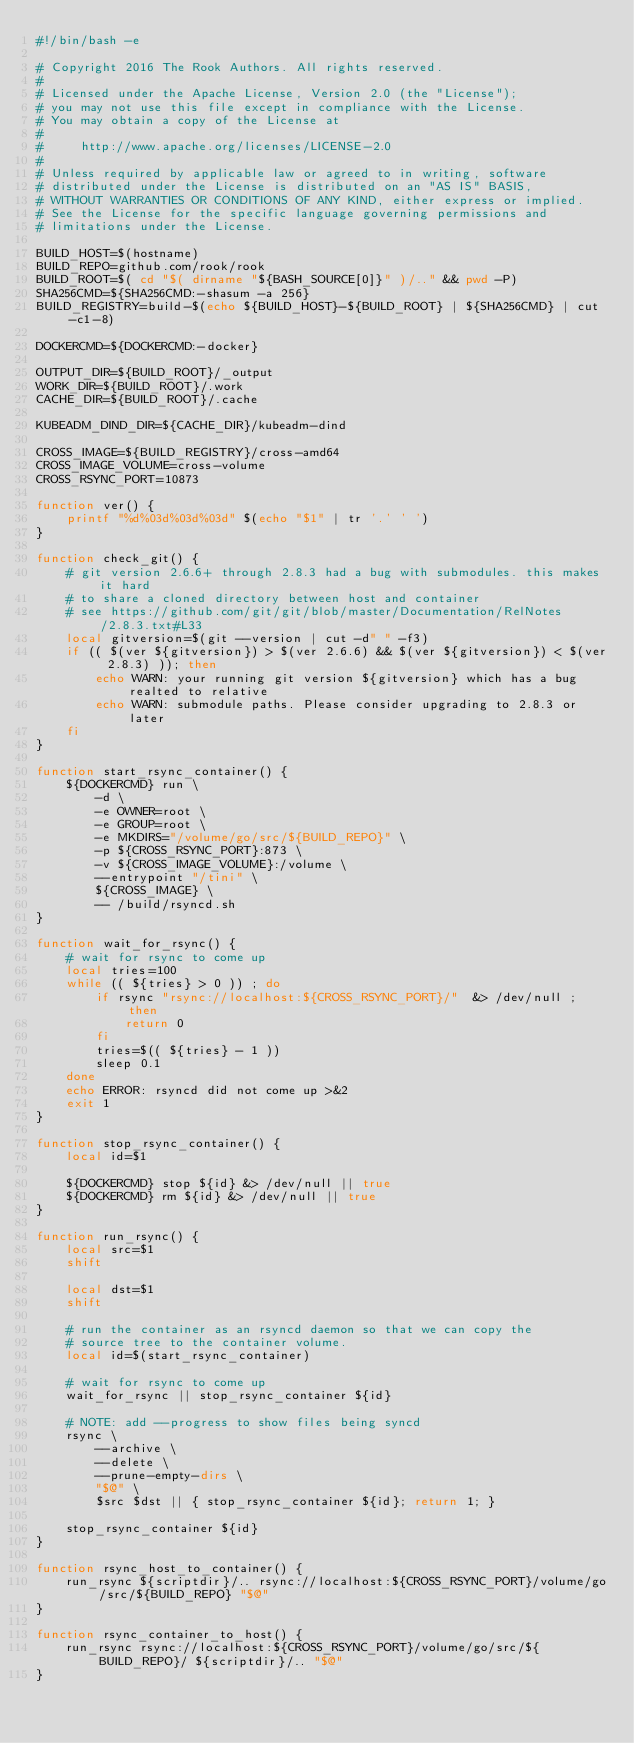<code> <loc_0><loc_0><loc_500><loc_500><_Bash_>#!/bin/bash -e

# Copyright 2016 The Rook Authors. All rights reserved.
#
# Licensed under the Apache License, Version 2.0 (the "License");
# you may not use this file except in compliance with the License.
# You may obtain a copy of the License at
#
#     http://www.apache.org/licenses/LICENSE-2.0
#
# Unless required by applicable law or agreed to in writing, software
# distributed under the License is distributed on an "AS IS" BASIS,
# WITHOUT WARRANTIES OR CONDITIONS OF ANY KIND, either express or implied.
# See the License for the specific language governing permissions and
# limitations under the License.

BUILD_HOST=$(hostname)
BUILD_REPO=github.com/rook/rook
BUILD_ROOT=$( cd "$( dirname "${BASH_SOURCE[0]}" )/.." && pwd -P)
SHA256CMD=${SHA256CMD:-shasum -a 256}
BUILD_REGISTRY=build-$(echo ${BUILD_HOST}-${BUILD_ROOT} | ${SHA256CMD} | cut -c1-8)

DOCKERCMD=${DOCKERCMD:-docker}

OUTPUT_DIR=${BUILD_ROOT}/_output
WORK_DIR=${BUILD_ROOT}/.work
CACHE_DIR=${BUILD_ROOT}/.cache

KUBEADM_DIND_DIR=${CACHE_DIR}/kubeadm-dind

CROSS_IMAGE=${BUILD_REGISTRY}/cross-amd64
CROSS_IMAGE_VOLUME=cross-volume
CROSS_RSYNC_PORT=10873

function ver() {
    printf "%d%03d%03d%03d" $(echo "$1" | tr '.' ' ')
}

function check_git() {
    # git version 2.6.6+ through 2.8.3 had a bug with submodules. this makes it hard
    # to share a cloned directory between host and container
    # see https://github.com/git/git/blob/master/Documentation/RelNotes/2.8.3.txt#L33
    local gitversion=$(git --version | cut -d" " -f3)
    if (( $(ver ${gitversion}) > $(ver 2.6.6) && $(ver ${gitversion}) < $(ver 2.8.3) )); then
        echo WARN: your running git version ${gitversion} which has a bug realted to relative
        echo WARN: submodule paths. Please consider upgrading to 2.8.3 or later
    fi
}

function start_rsync_container() {
    ${DOCKERCMD} run \
        -d \
        -e OWNER=root \
        -e GROUP=root \
        -e MKDIRS="/volume/go/src/${BUILD_REPO}" \
        -p ${CROSS_RSYNC_PORT}:873 \
        -v ${CROSS_IMAGE_VOLUME}:/volume \
        --entrypoint "/tini" \
        ${CROSS_IMAGE} \
        -- /build/rsyncd.sh
}

function wait_for_rsync() {
    # wait for rsync to come up
    local tries=100
    while (( ${tries} > 0 )) ; do
        if rsync "rsync://localhost:${CROSS_RSYNC_PORT}/"  &> /dev/null ; then
            return 0
        fi
        tries=$(( ${tries} - 1 ))
        sleep 0.1
    done
    echo ERROR: rsyncd did not come up >&2
    exit 1
}

function stop_rsync_container() {
    local id=$1

    ${DOCKERCMD} stop ${id} &> /dev/null || true
    ${DOCKERCMD} rm ${id} &> /dev/null || true
}

function run_rsync() {
    local src=$1
    shift

    local dst=$1
    shift

    # run the container as an rsyncd daemon so that we can copy the
    # source tree to the container volume.
    local id=$(start_rsync_container)

    # wait for rsync to come up
    wait_for_rsync || stop_rsync_container ${id}

    # NOTE: add --progress to show files being syncd
    rsync \
        --archive \
        --delete \
        --prune-empty-dirs \
        "$@" \
        $src $dst || { stop_rsync_container ${id}; return 1; }

    stop_rsync_container ${id}
}

function rsync_host_to_container() {
    run_rsync ${scriptdir}/.. rsync://localhost:${CROSS_RSYNC_PORT}/volume/go/src/${BUILD_REPO} "$@"
}

function rsync_container_to_host() {
    run_rsync rsync://localhost:${CROSS_RSYNC_PORT}/volume/go/src/${BUILD_REPO}/ ${scriptdir}/.. "$@"
}
</code> 